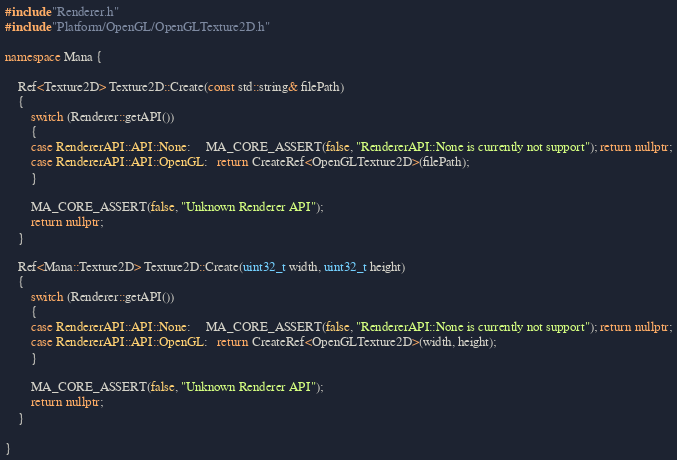<code> <loc_0><loc_0><loc_500><loc_500><_C++_>
#include "Renderer.h"
#include "Platform/OpenGL/OpenGLTexture2D.h"

namespace Mana {

    Ref<Texture2D> Texture2D::Create(const std::string& filePath)
    {
        switch (Renderer::getAPI())
        {
        case RendererAPI::API::None:     MA_CORE_ASSERT(false, "RendererAPI::None is currently not support"); return nullptr;
        case RendererAPI::API::OpenGL:   return CreateRef<OpenGLTexture2D>(filePath);
        }

        MA_CORE_ASSERT(false, "Unknown Renderer API");
        return nullptr;
    }

    Ref<Mana::Texture2D> Texture2D::Create(uint32_t width, uint32_t height)
    {
        switch (Renderer::getAPI())
        {
        case RendererAPI::API::None:     MA_CORE_ASSERT(false, "RendererAPI::None is currently not support"); return nullptr;
        case RendererAPI::API::OpenGL:   return CreateRef<OpenGLTexture2D>(width, height);
        }

        MA_CORE_ASSERT(false, "Unknown Renderer API");
        return nullptr;
    }

}</code> 